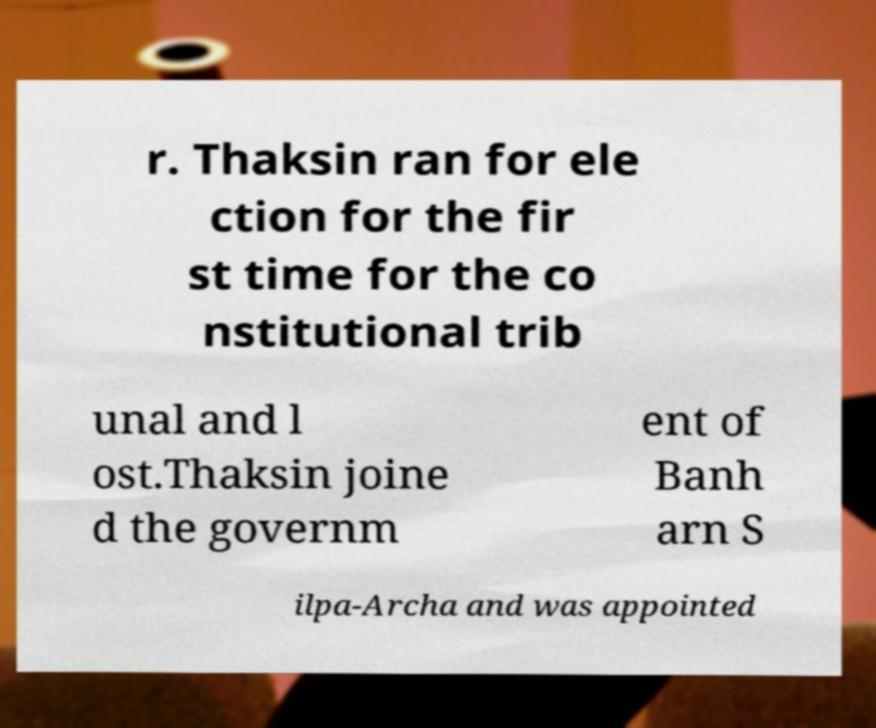Please identify and transcribe the text found in this image. r. Thaksin ran for ele ction for the fir st time for the co nstitutional trib unal and l ost.Thaksin joine d the governm ent of Banh arn S ilpa-Archa and was appointed 